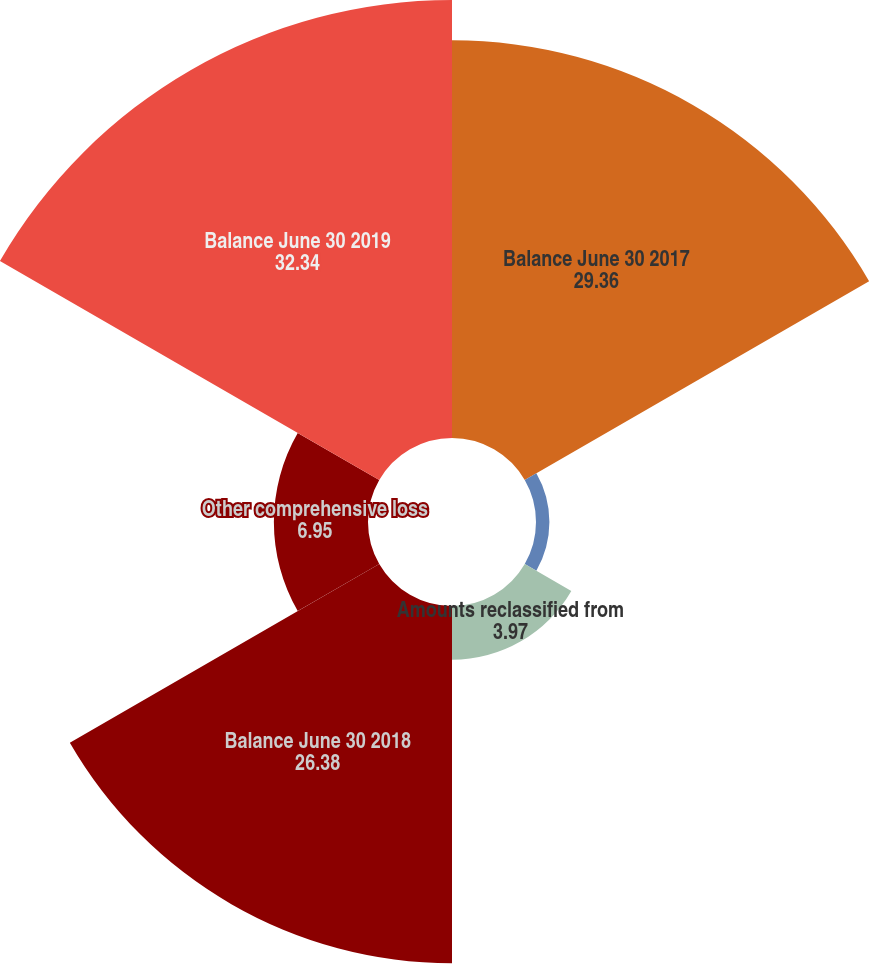Convert chart. <chart><loc_0><loc_0><loc_500><loc_500><pie_chart><fcel>Balance June 30 2017<fcel>Other comprehensive income<fcel>Amounts reclassified from<fcel>Balance June 30 2018<fcel>Other comprehensive loss<fcel>Balance June 30 2019<nl><fcel>29.36%<fcel>0.99%<fcel>3.97%<fcel>26.38%<fcel>6.95%<fcel>32.34%<nl></chart> 